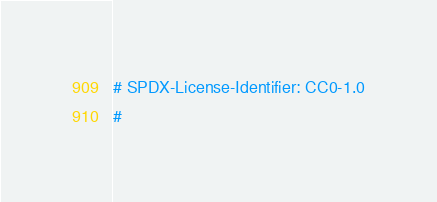<code> <loc_0><loc_0><loc_500><loc_500><_Python_># SPDX-License-Identifier: CC0-1.0
#</code> 